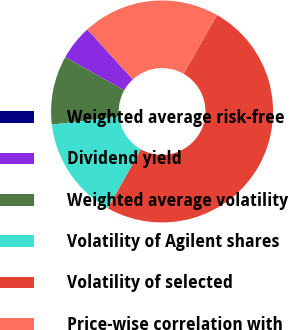Convert chart. <chart><loc_0><loc_0><loc_500><loc_500><pie_chart><fcel>Weighted average risk-free<fcel>Dividend yield<fcel>Weighted average volatility<fcel>Volatility of Agilent shares<fcel>Volatility of selected<fcel>Price-wise correlation with<nl><fcel>0.07%<fcel>5.05%<fcel>10.03%<fcel>15.01%<fcel>49.87%<fcel>19.99%<nl></chart> 